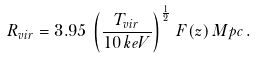<formula> <loc_0><loc_0><loc_500><loc_500>R _ { v i r } = 3 . 9 5 \, \left ( \frac { T _ { v i r } } { 1 0 \, k e V } \right ) ^ { \frac { 1 } { 2 } } \, F ( z ) \, M p c \, .</formula> 